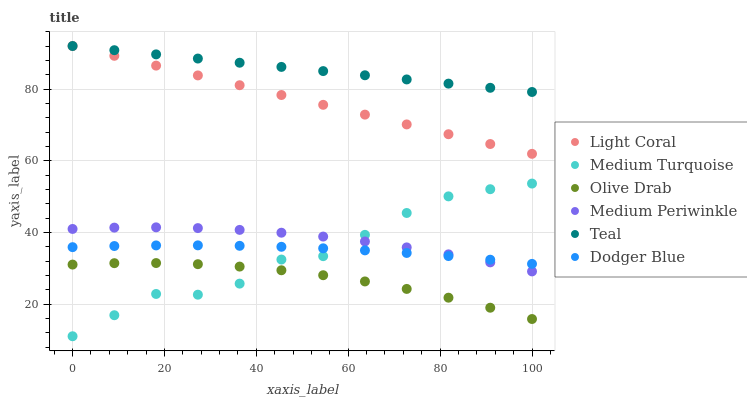Does Olive Drab have the minimum area under the curve?
Answer yes or no. Yes. Does Teal have the maximum area under the curve?
Answer yes or no. Yes. Does Medium Periwinkle have the minimum area under the curve?
Answer yes or no. No. Does Medium Periwinkle have the maximum area under the curve?
Answer yes or no. No. Is Light Coral the smoothest?
Answer yes or no. Yes. Is Medium Turquoise the roughest?
Answer yes or no. Yes. Is Medium Periwinkle the smoothest?
Answer yes or no. No. Is Medium Periwinkle the roughest?
Answer yes or no. No. Does Medium Turquoise have the lowest value?
Answer yes or no. Yes. Does Medium Periwinkle have the lowest value?
Answer yes or no. No. Does Teal have the highest value?
Answer yes or no. Yes. Does Medium Periwinkle have the highest value?
Answer yes or no. No. Is Medium Periwinkle less than Teal?
Answer yes or no. Yes. Is Dodger Blue greater than Olive Drab?
Answer yes or no. Yes. Does Medium Turquoise intersect Medium Periwinkle?
Answer yes or no. Yes. Is Medium Turquoise less than Medium Periwinkle?
Answer yes or no. No. Is Medium Turquoise greater than Medium Periwinkle?
Answer yes or no. No. Does Medium Periwinkle intersect Teal?
Answer yes or no. No. 